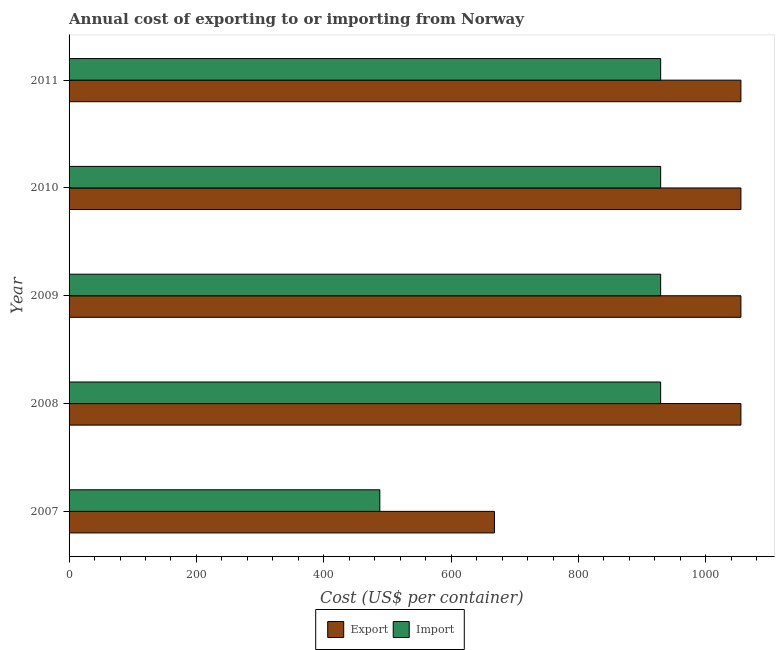Are the number of bars per tick equal to the number of legend labels?
Provide a succinct answer. Yes. Are the number of bars on each tick of the Y-axis equal?
Your answer should be very brief. Yes. How many bars are there on the 5th tick from the bottom?
Make the answer very short. 2. What is the label of the 4th group of bars from the top?
Your answer should be very brief. 2008. What is the export cost in 2011?
Provide a short and direct response. 1055. Across all years, what is the maximum import cost?
Provide a succinct answer. 929. Across all years, what is the minimum import cost?
Provide a succinct answer. 488. In which year was the export cost maximum?
Your response must be concise. 2008. What is the total export cost in the graph?
Your response must be concise. 4888. What is the difference between the import cost in 2007 and that in 2011?
Your response must be concise. -441. What is the difference between the export cost in 2009 and the import cost in 2010?
Your answer should be very brief. 126. What is the average export cost per year?
Your answer should be very brief. 977.6. In the year 2010, what is the difference between the import cost and export cost?
Give a very brief answer. -126. In how many years, is the import cost greater than 920 US$?
Offer a terse response. 4. What is the ratio of the export cost in 2009 to that in 2010?
Your answer should be compact. 1. Is the difference between the import cost in 2007 and 2011 greater than the difference between the export cost in 2007 and 2011?
Give a very brief answer. No. What is the difference between the highest and the second highest export cost?
Ensure brevity in your answer.  0. What is the difference between the highest and the lowest export cost?
Your answer should be very brief. 387. In how many years, is the export cost greater than the average export cost taken over all years?
Give a very brief answer. 4. What does the 1st bar from the top in 2008 represents?
Give a very brief answer. Import. What does the 2nd bar from the bottom in 2008 represents?
Offer a very short reply. Import. Are all the bars in the graph horizontal?
Your answer should be compact. Yes. How many years are there in the graph?
Provide a succinct answer. 5. What is the difference between two consecutive major ticks on the X-axis?
Keep it short and to the point. 200. How are the legend labels stacked?
Your answer should be very brief. Horizontal. What is the title of the graph?
Keep it short and to the point. Annual cost of exporting to or importing from Norway. What is the label or title of the X-axis?
Your answer should be very brief. Cost (US$ per container). What is the Cost (US$ per container) in Export in 2007?
Your response must be concise. 668. What is the Cost (US$ per container) of Import in 2007?
Give a very brief answer. 488. What is the Cost (US$ per container) of Export in 2008?
Keep it short and to the point. 1055. What is the Cost (US$ per container) in Import in 2008?
Make the answer very short. 929. What is the Cost (US$ per container) in Export in 2009?
Your response must be concise. 1055. What is the Cost (US$ per container) of Import in 2009?
Keep it short and to the point. 929. What is the Cost (US$ per container) of Export in 2010?
Offer a terse response. 1055. What is the Cost (US$ per container) of Import in 2010?
Offer a terse response. 929. What is the Cost (US$ per container) in Export in 2011?
Make the answer very short. 1055. What is the Cost (US$ per container) of Import in 2011?
Keep it short and to the point. 929. Across all years, what is the maximum Cost (US$ per container) in Export?
Your response must be concise. 1055. Across all years, what is the maximum Cost (US$ per container) of Import?
Ensure brevity in your answer.  929. Across all years, what is the minimum Cost (US$ per container) of Export?
Keep it short and to the point. 668. Across all years, what is the minimum Cost (US$ per container) in Import?
Make the answer very short. 488. What is the total Cost (US$ per container) of Export in the graph?
Ensure brevity in your answer.  4888. What is the total Cost (US$ per container) of Import in the graph?
Offer a terse response. 4204. What is the difference between the Cost (US$ per container) of Export in 2007 and that in 2008?
Your answer should be very brief. -387. What is the difference between the Cost (US$ per container) of Import in 2007 and that in 2008?
Provide a short and direct response. -441. What is the difference between the Cost (US$ per container) in Export in 2007 and that in 2009?
Offer a very short reply. -387. What is the difference between the Cost (US$ per container) in Import in 2007 and that in 2009?
Your answer should be compact. -441. What is the difference between the Cost (US$ per container) in Export in 2007 and that in 2010?
Provide a short and direct response. -387. What is the difference between the Cost (US$ per container) of Import in 2007 and that in 2010?
Keep it short and to the point. -441. What is the difference between the Cost (US$ per container) in Export in 2007 and that in 2011?
Offer a very short reply. -387. What is the difference between the Cost (US$ per container) of Import in 2007 and that in 2011?
Make the answer very short. -441. What is the difference between the Cost (US$ per container) in Import in 2008 and that in 2009?
Your answer should be very brief. 0. What is the difference between the Cost (US$ per container) in Export in 2008 and that in 2010?
Ensure brevity in your answer.  0. What is the difference between the Cost (US$ per container) in Import in 2008 and that in 2010?
Your response must be concise. 0. What is the difference between the Cost (US$ per container) in Import in 2008 and that in 2011?
Give a very brief answer. 0. What is the difference between the Cost (US$ per container) of Export in 2009 and that in 2010?
Give a very brief answer. 0. What is the difference between the Cost (US$ per container) in Import in 2010 and that in 2011?
Offer a terse response. 0. What is the difference between the Cost (US$ per container) in Export in 2007 and the Cost (US$ per container) in Import in 2008?
Your answer should be compact. -261. What is the difference between the Cost (US$ per container) in Export in 2007 and the Cost (US$ per container) in Import in 2009?
Make the answer very short. -261. What is the difference between the Cost (US$ per container) of Export in 2007 and the Cost (US$ per container) of Import in 2010?
Give a very brief answer. -261. What is the difference between the Cost (US$ per container) of Export in 2007 and the Cost (US$ per container) of Import in 2011?
Keep it short and to the point. -261. What is the difference between the Cost (US$ per container) in Export in 2008 and the Cost (US$ per container) in Import in 2009?
Your response must be concise. 126. What is the difference between the Cost (US$ per container) of Export in 2008 and the Cost (US$ per container) of Import in 2010?
Keep it short and to the point. 126. What is the difference between the Cost (US$ per container) in Export in 2008 and the Cost (US$ per container) in Import in 2011?
Ensure brevity in your answer.  126. What is the difference between the Cost (US$ per container) of Export in 2009 and the Cost (US$ per container) of Import in 2010?
Ensure brevity in your answer.  126. What is the difference between the Cost (US$ per container) of Export in 2009 and the Cost (US$ per container) of Import in 2011?
Keep it short and to the point. 126. What is the difference between the Cost (US$ per container) of Export in 2010 and the Cost (US$ per container) of Import in 2011?
Your answer should be compact. 126. What is the average Cost (US$ per container) in Export per year?
Offer a very short reply. 977.6. What is the average Cost (US$ per container) of Import per year?
Ensure brevity in your answer.  840.8. In the year 2007, what is the difference between the Cost (US$ per container) in Export and Cost (US$ per container) in Import?
Your response must be concise. 180. In the year 2008, what is the difference between the Cost (US$ per container) of Export and Cost (US$ per container) of Import?
Give a very brief answer. 126. In the year 2009, what is the difference between the Cost (US$ per container) in Export and Cost (US$ per container) in Import?
Your answer should be compact. 126. In the year 2010, what is the difference between the Cost (US$ per container) of Export and Cost (US$ per container) of Import?
Give a very brief answer. 126. In the year 2011, what is the difference between the Cost (US$ per container) in Export and Cost (US$ per container) in Import?
Offer a very short reply. 126. What is the ratio of the Cost (US$ per container) of Export in 2007 to that in 2008?
Your answer should be very brief. 0.63. What is the ratio of the Cost (US$ per container) in Import in 2007 to that in 2008?
Offer a terse response. 0.53. What is the ratio of the Cost (US$ per container) of Export in 2007 to that in 2009?
Provide a short and direct response. 0.63. What is the ratio of the Cost (US$ per container) of Import in 2007 to that in 2009?
Offer a very short reply. 0.53. What is the ratio of the Cost (US$ per container) of Export in 2007 to that in 2010?
Your response must be concise. 0.63. What is the ratio of the Cost (US$ per container) in Import in 2007 to that in 2010?
Your response must be concise. 0.53. What is the ratio of the Cost (US$ per container) of Export in 2007 to that in 2011?
Give a very brief answer. 0.63. What is the ratio of the Cost (US$ per container) in Import in 2007 to that in 2011?
Your answer should be compact. 0.53. What is the ratio of the Cost (US$ per container) in Import in 2008 to that in 2010?
Keep it short and to the point. 1. What is the ratio of the Cost (US$ per container) of Export in 2010 to that in 2011?
Your answer should be very brief. 1. What is the difference between the highest and the second highest Cost (US$ per container) of Export?
Your answer should be compact. 0. What is the difference between the highest and the lowest Cost (US$ per container) in Export?
Keep it short and to the point. 387. What is the difference between the highest and the lowest Cost (US$ per container) in Import?
Offer a terse response. 441. 